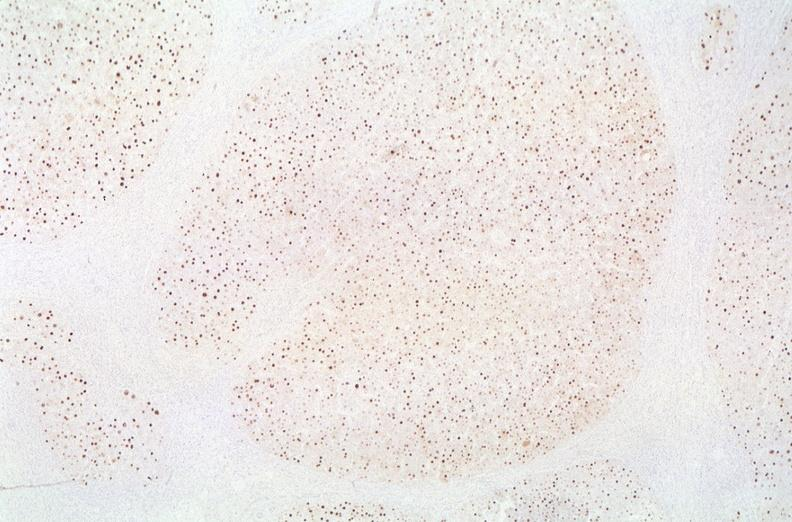s lesion in dome of uterus present?
Answer the question using a single word or phrase. No 